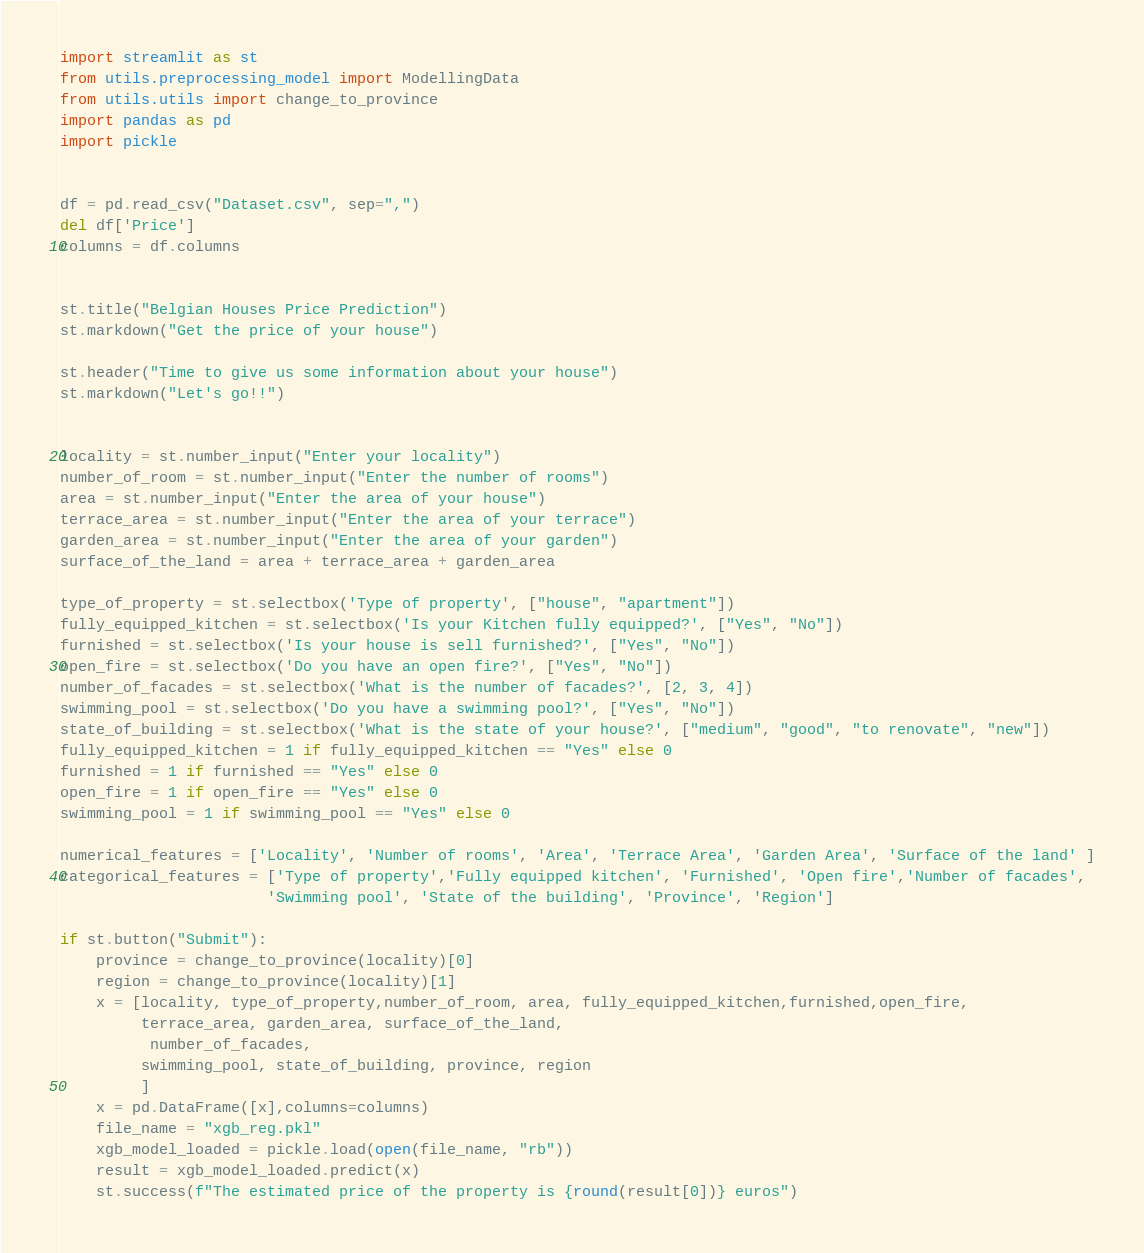Convert code to text. <code><loc_0><loc_0><loc_500><loc_500><_Python_>import streamlit as st
from utils.preprocessing_model import ModellingData
from utils.utils import change_to_province
import pandas as pd
import pickle


df = pd.read_csv("Dataset.csv", sep=",")
del df['Price']
columns = df.columns


st.title("Belgian Houses Price Prediction")
st.markdown("Get the price of your house")

st.header("Time to give us some information about your house")
st.markdown("Let's go!!")


locality = st.number_input("Enter your locality")
number_of_room = st.number_input("Enter the number of rooms")
area = st.number_input("Enter the area of your house")
terrace_area = st.number_input("Enter the area of your terrace")
garden_area = st.number_input("Enter the area of your garden")
surface_of_the_land = area + terrace_area + garden_area

type_of_property = st.selectbox('Type of property', ["house", "apartment"])
fully_equipped_kitchen = st.selectbox('Is your Kitchen fully equipped?', ["Yes", "No"])
furnished = st.selectbox('Is your house is sell furnished?', ["Yes", "No"])
open_fire = st.selectbox('Do you have an open fire?', ["Yes", "No"])
number_of_facades = st.selectbox('What is the number of facades?', [2, 3, 4])
swimming_pool = st.selectbox('Do you have a swimming pool?', ["Yes", "No"])
state_of_building = st.selectbox('What is the state of your house?', ["medium", "good", "to renovate", "new"])
fully_equipped_kitchen = 1 if fully_equipped_kitchen == "Yes" else 0
furnished = 1 if furnished == "Yes" else 0
open_fire = 1 if open_fire == "Yes" else 0
swimming_pool = 1 if swimming_pool == "Yes" else 0

numerical_features = ['Locality', 'Number of rooms', 'Area', 'Terrace Area', 'Garden Area', 'Surface of the land' ]
categorical_features = ['Type of property','Fully equipped kitchen', 'Furnished', 'Open fire','Number of facades',
                       'Swimming pool', 'State of the building', 'Province', 'Region']

if st.button("Submit"):
    province = change_to_province(locality)[0]
    region = change_to_province(locality)[1]
    x = [locality, type_of_property,number_of_room, area, fully_equipped_kitchen,furnished,open_fire,
         terrace_area, garden_area, surface_of_the_land,
          number_of_facades,
         swimming_pool, state_of_building, province, region
         ]
    x = pd.DataFrame([x],columns=columns)
    file_name = "xgb_reg.pkl"
    xgb_model_loaded = pickle.load(open(file_name, "rb"))
    result = xgb_model_loaded.predict(x)
    st.success(f"The estimated price of the property is {round(result[0])} euros")
</code> 